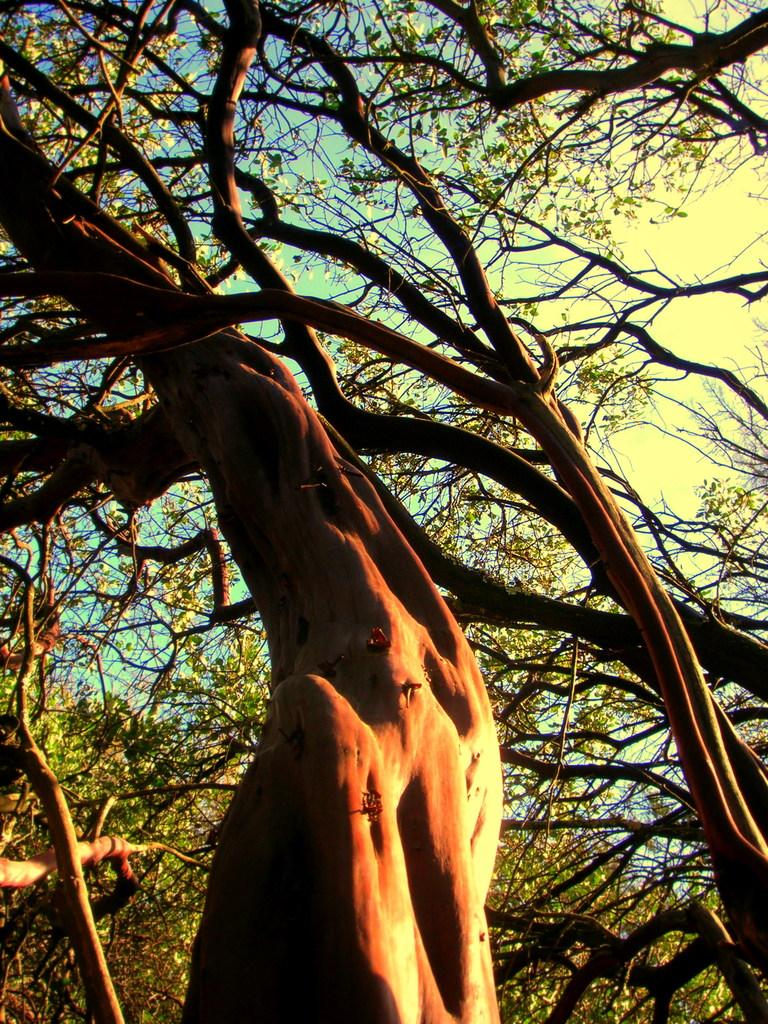What type of vegetation is visible in the image? There are many trees in the image. What is visible at the top of the image? The sky is visible at the top of the image. What can be seen in the sky in the image? Clouds are present in the sky. What type of property is being traded in the image? There is no indication of any property or trade in the image; it primarily features trees and the sky. 